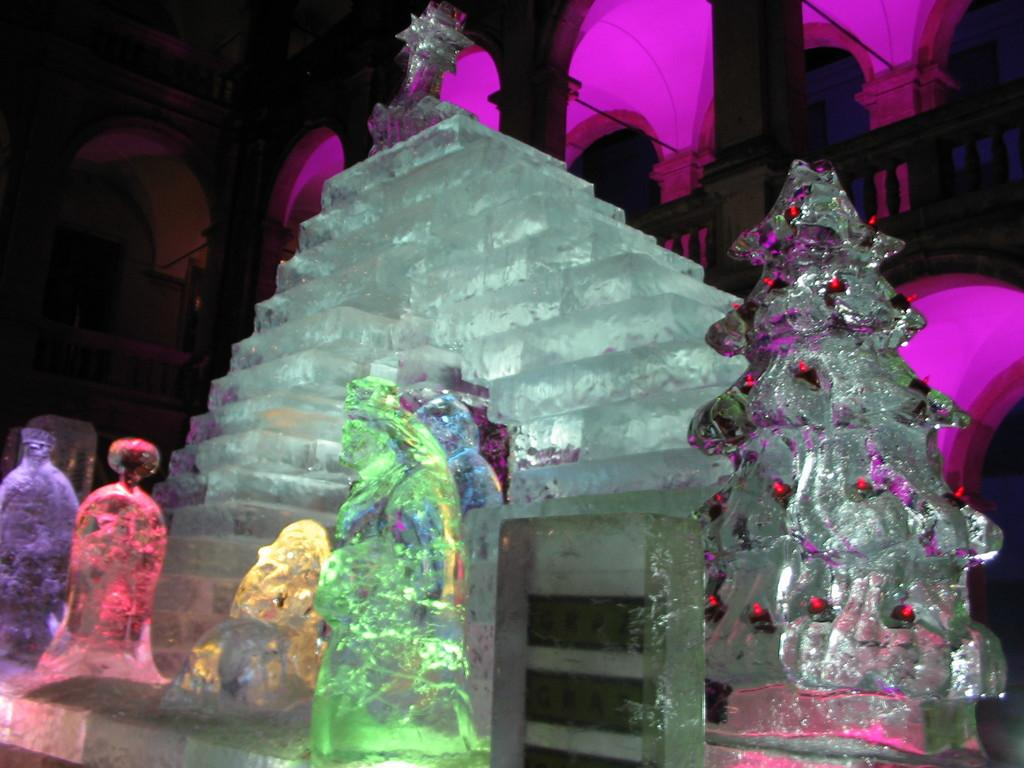What type of material is used to create the sculptures in the foreground of the image? The sculptures in the foreground are made with white stone. Are there any additional features on the sculptures? Yes, there are lights attached to the sculptures. What can be seen in the background of the image? There is a building in the background of the image. What color is the light in the background? There is a pink light in the background of the image. How does the wind affect the sculptures in the image? There is no mention of wind in the image, so we cannot determine its effect on the sculptures. 